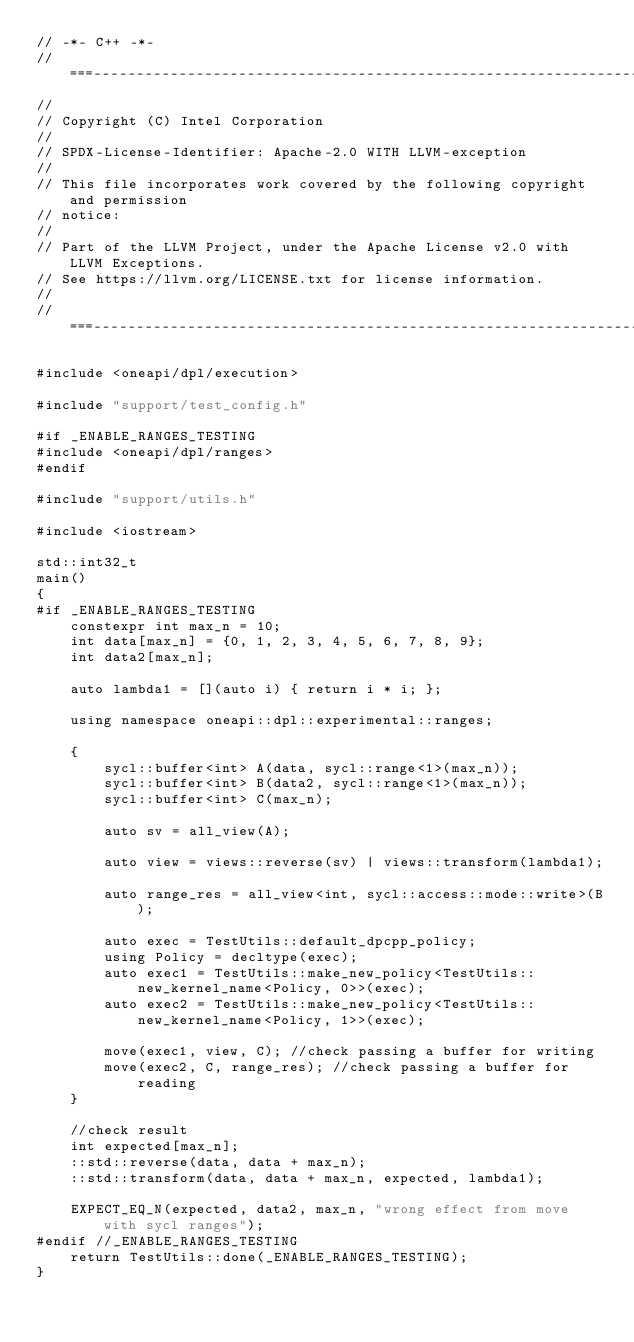Convert code to text. <code><loc_0><loc_0><loc_500><loc_500><_C++_>// -*- C++ -*-
//===----------------------------------------------------------------------===//
//
// Copyright (C) Intel Corporation
//
// SPDX-License-Identifier: Apache-2.0 WITH LLVM-exception
//
// This file incorporates work covered by the following copyright and permission
// notice:
//
// Part of the LLVM Project, under the Apache License v2.0 with LLVM Exceptions.
// See https://llvm.org/LICENSE.txt for license information.
//
//===----------------------------------------------------------------------===//

#include <oneapi/dpl/execution>

#include "support/test_config.h"

#if _ENABLE_RANGES_TESTING
#include <oneapi/dpl/ranges>
#endif

#include "support/utils.h"

#include <iostream>

std::int32_t
main()
{
#if _ENABLE_RANGES_TESTING
    constexpr int max_n = 10;
    int data[max_n] = {0, 1, 2, 3, 4, 5, 6, 7, 8, 9};
    int data2[max_n];

    auto lambda1 = [](auto i) { return i * i; };

    using namespace oneapi::dpl::experimental::ranges;

    {
        sycl::buffer<int> A(data, sycl::range<1>(max_n));
        sycl::buffer<int> B(data2, sycl::range<1>(max_n));
        sycl::buffer<int> C(max_n);

        auto sv = all_view(A);

        auto view = views::reverse(sv) | views::transform(lambda1);

        auto range_res = all_view<int, sycl::access::mode::write>(B);

        auto exec = TestUtils::default_dpcpp_policy;
        using Policy = decltype(exec);
        auto exec1 = TestUtils::make_new_policy<TestUtils::new_kernel_name<Policy, 0>>(exec);
        auto exec2 = TestUtils::make_new_policy<TestUtils::new_kernel_name<Policy, 1>>(exec);

        move(exec1, view, C); //check passing a buffer for writing
        move(exec2, C, range_res); //check passing a buffer for reading
    }

    //check result
    int expected[max_n];
    ::std::reverse(data, data + max_n);
    ::std::transform(data, data + max_n, expected, lambda1);

    EXPECT_EQ_N(expected, data2, max_n, "wrong effect from move with sycl ranges");
#endif //_ENABLE_RANGES_TESTING
    return TestUtils::done(_ENABLE_RANGES_TESTING);
}
</code> 